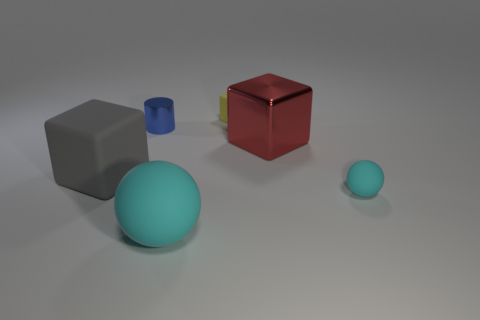Add 2 cyan spheres. How many objects exist? 8 Subtract all big blocks. How many blocks are left? 1 Subtract all blue cubes. Subtract all red balls. How many cubes are left? 3 Subtract all cylinders. How many objects are left? 5 Add 6 small yellow rubber objects. How many small yellow rubber objects exist? 7 Subtract 0 blue spheres. How many objects are left? 6 Subtract all large blue rubber spheres. Subtract all large red shiny things. How many objects are left? 5 Add 6 yellow blocks. How many yellow blocks are left? 7 